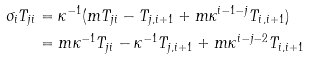Convert formula to latex. <formula><loc_0><loc_0><loc_500><loc_500>\sigma _ { i } T _ { j i } & = \kappa ^ { - 1 } ( m T _ { j i } - T _ { j , i + 1 } + m \kappa ^ { i - 1 - j } T _ { i , i + 1 } ) \\ & = m \kappa ^ { - 1 } T _ { j i } - \kappa ^ { - 1 } T _ { j , i + 1 } + m \kappa ^ { i - j - 2 } T _ { i , i + 1 }</formula> 